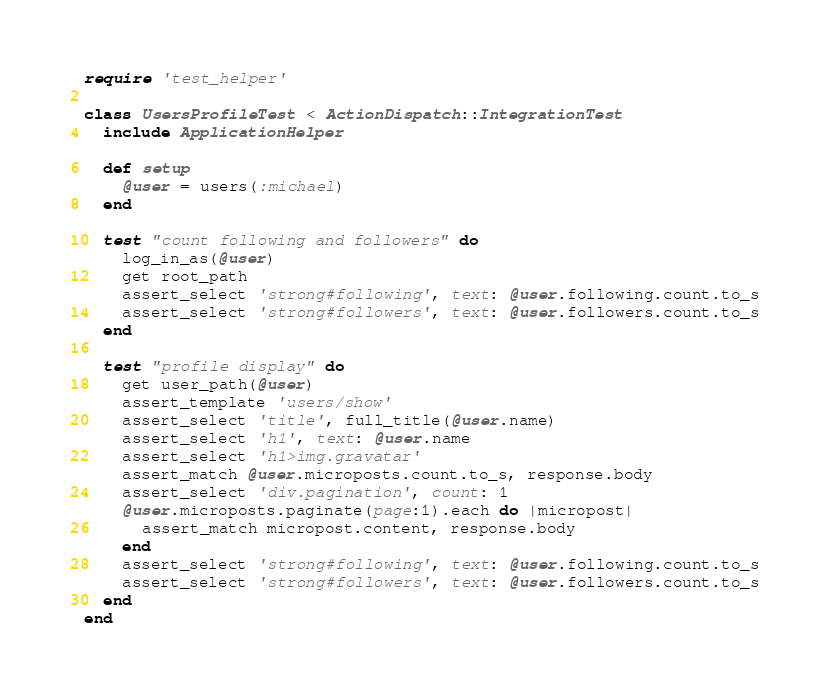<code> <loc_0><loc_0><loc_500><loc_500><_Ruby_>require 'test_helper'

class UsersProfileTest < ActionDispatch::IntegrationTest
  include ApplicationHelper

  def setup
    @user = users(:michael)
  end

  test "count following and followers" do
    log_in_as(@user)
    get root_path
    assert_select 'strong#following', text: @user.following.count.to_s
    assert_select 'strong#followers', text: @user.followers.count.to_s
  end

  test "profile display" do
    get user_path(@user)
    assert_template 'users/show'
    assert_select 'title', full_title(@user.name)
    assert_select 'h1', text: @user.name
    assert_select 'h1>img.gravatar'
    assert_match @user.microposts.count.to_s, response.body
    assert_select 'div.pagination', count: 1
    @user.microposts.paginate(page:1).each do |micropost|
      assert_match micropost.content, response.body
    end
    assert_select 'strong#following', text: @user.following.count.to_s
    assert_select 'strong#followers', text: @user.followers.count.to_s
  end
end
</code> 